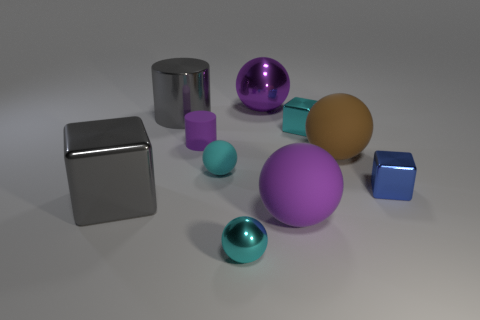What material is the cube that is the same color as the large cylinder?
Offer a very short reply. Metal. How many cyan matte balls are to the right of the matte ball in front of the cyan matte thing?
Offer a terse response. 0. Do the small shiny block behind the matte cylinder and the tiny metal block in front of the brown rubber thing have the same color?
Your answer should be compact. No. There is a blue object that is the same size as the cyan metal ball; what is its material?
Your response must be concise. Metal. What shape is the rubber object that is to the right of the small cyan shiny thing behind the matte ball that is in front of the big gray metallic cube?
Ensure brevity in your answer.  Sphere. What shape is the brown thing that is the same size as the purple rubber sphere?
Provide a succinct answer. Sphere. There is a cyan shiny thing that is to the right of the big purple thing in front of the gray cube; how many purple objects are behind it?
Provide a succinct answer. 1. Are there more small things in front of the tiny purple object than big gray cubes left of the big brown rubber thing?
Give a very brief answer. Yes. How many large purple objects are the same shape as the tiny purple rubber object?
Your answer should be very brief. 0. How many objects are either metal things that are on the left side of the purple cylinder or big objects that are to the right of the large purple matte ball?
Give a very brief answer. 3. 